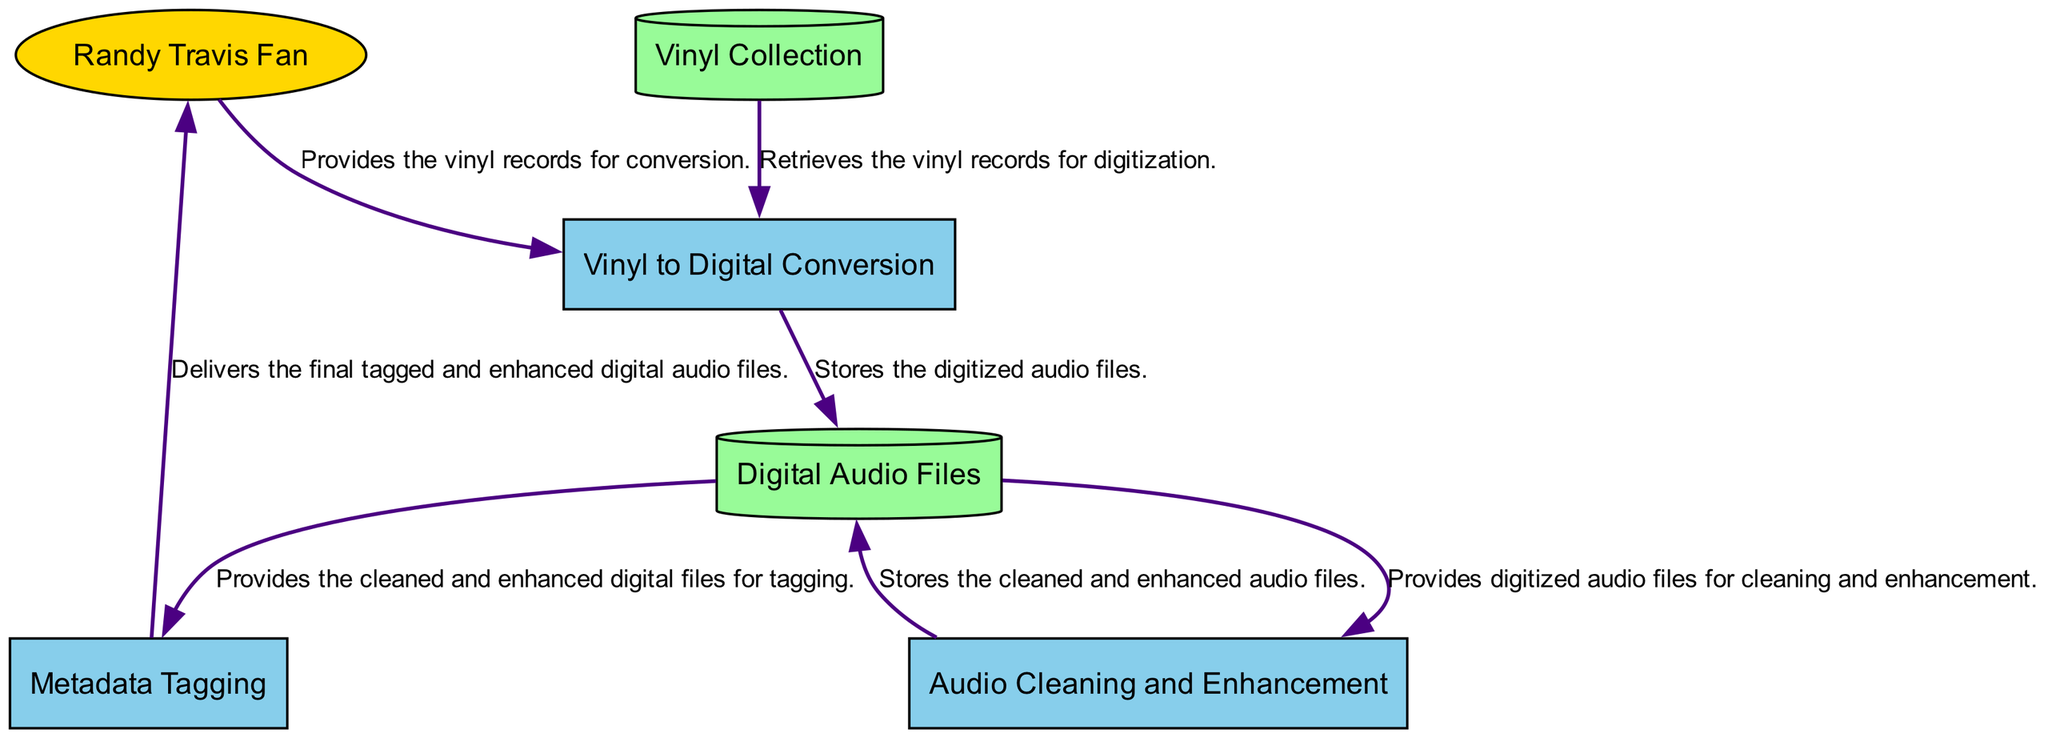What is the primary purpose of the process labeled "Vinyl to Digital Conversion"? The diagram specifies that the process labeled "Vinyl to Digital Conversion" is focused on converting Randy Travis's vinyl records into digital format.
Answer: Converting vinyl records How many external entities are represented in the diagram? The diagram shows one external entity, which is the "Randy Travis Fan," indicating that it is the only source for the vinyl records and recipient of the digital files.
Answer: One What does the "Digital Audio Files" store contain? According to the diagram, the "Digital Audio Files" data store contains the digitized audio files after they are produced by the "Vinyl to Digital Conversion" process and also includes the cleaned and enhanced audio files from later processes.
Answer: Digitized audio files Which process receives the cleaned and enhanced audio files? From the diagram, it is clear that the process labeled "Metadata Tagging" receives the cleaned and enhanced audio files stored in "Digital Audio Files."
Answer: Metadata Tagging How many processes are there in total within the diagram? The diagram identifies three distinct processes: "Vinyl to Digital Conversion," "Audio Cleaning and Enhancement," and "Metadata Tagging," leading to a total of three processes represented.
Answer: Three What is the final output from the process "Metadata Tagging"? The output from the "Metadata Tagging" process as illustrated in the diagram is the final tagged and enhanced digital audio files delivered to the "Randy Travis Fan."
Answer: Tagged and enhanced digital audio files Which entity provides the vinyl records for conversion? The diagram indicates that the external entity "Randy Travis Fan" provides the vinyl records for conversion, making it the source for this initial step.
Answer: Randy Travis Fan What is stored in the "Vinyl Collection"? The diagram states that the "Vinyl Collection" is a collection of Randy Travis's vinyl records, which serves as the source material for digitization.
Answer: Vinyl records 